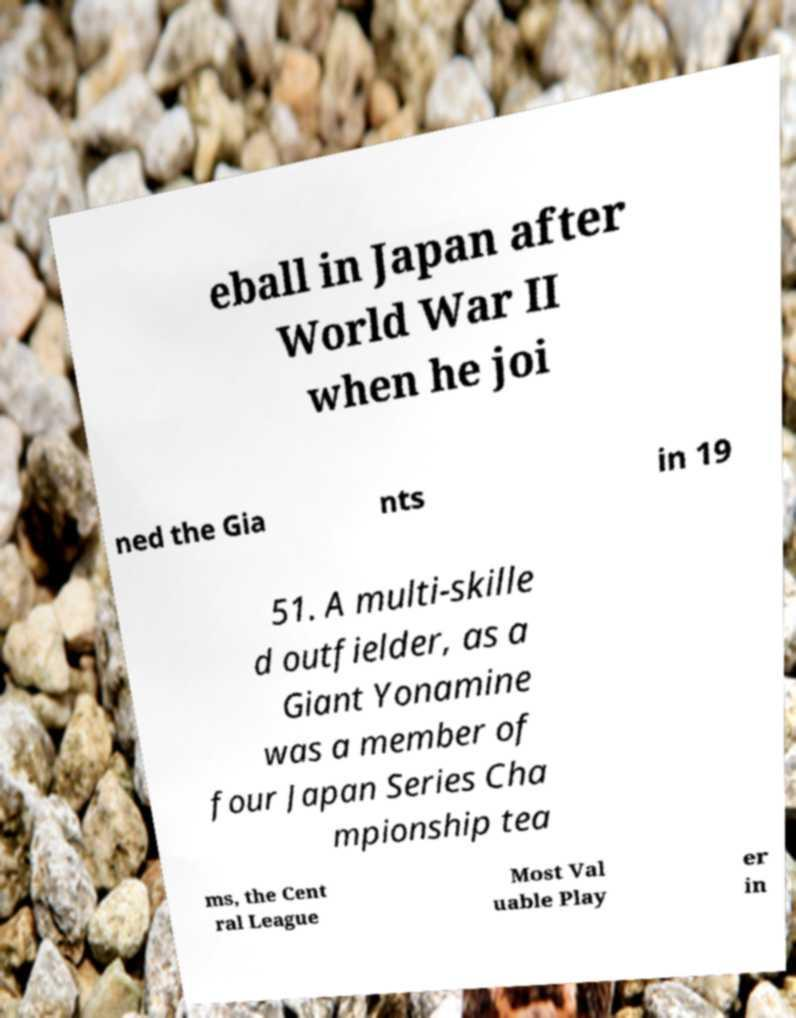Could you assist in decoding the text presented in this image and type it out clearly? eball in Japan after World War II when he joi ned the Gia nts in 19 51. A multi-skille d outfielder, as a Giant Yonamine was a member of four Japan Series Cha mpionship tea ms, the Cent ral League Most Val uable Play er in 